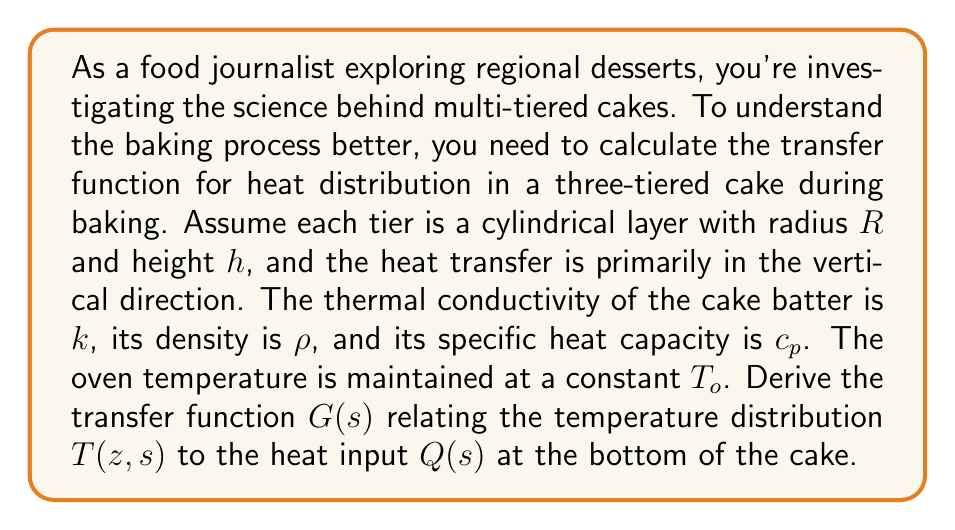Solve this math problem. To solve this problem, we'll follow these steps:

1) First, we need to set up the heat equation for the cake. In one dimension (vertical), it's:

   $$\rho c_p \frac{\partial T}{\partial t} = k \frac{\partial^2 T}{\partial z^2}$$

2) We'll assume the cake is symmetric radially, so we only consider heat transfer in the z-direction.

3) Taking the Laplace transform of both sides with respect to time:

   $$\rho c_p (sT(z,s) - T(z,0)) = k \frac{\partial^2 T(z,s)}{\partial z^2}$$

4) Assuming initial temperature is uniform, $T(z,0) = T_i$, we get:

   $$\rho c_p sT(z,s) - \rho c_p T_i = k \frac{\partial^2 T(z,s)}{\partial z^2}$$

5) Rearranging:

   $$\frac{\partial^2 T(z,s)}{\partial z^2} - \frac{\rho c_p s}{k}T(z,s) = -\frac{\rho c_p T_i}{k}$$

6) This is a second-order ODE. Its general solution is:

   $$T(z,s) = A e^{\sqrt{\frac{\rho c_p s}{k}}z} + B e^{-\sqrt{\frac{\rho c_p s}{k}}z} + \frac{T_i}{s}$$

7) We need boundary conditions. At the bottom (z=0), the heat flux is $Q(s)/A$, where $A = \pi R^2$ is the area of the cake tier. At the top (z=3h), we assume the temperature is the oven temperature $T_o$. These give us:

   $$-k\frac{\partial T}{\partial z}\bigg|_{z=0} = \frac{Q(s)}{\pi R^2}$$
   $$T(3h,s) = \frac{T_o}{s}$$

8) Applying these boundary conditions to solve for A and B, we get:

   $$A = \frac{Q(s)}{k\sqrt{\frac{\rho c_p s}{k}}\pi R^2} \cdot \frac{e^{3h\sqrt{\frac{\rho c_p s}{k}}}}{e^{3h\sqrt{\frac{\rho c_p s}{k}}} + e^{-3h\sqrt{\frac{\rho c_p s}{k}}}}$$

   $$B = \frac{Q(s)}{k\sqrt{\frac{\rho c_p s}{k}}\pi R^2} \cdot \frac{1}{e^{3h\sqrt{\frac{\rho c_p s}{k}}} + e^{-3h\sqrt{\frac{\rho c_p s}{k}}}}$$

9) The transfer function $G(s)$ is defined as $T(z,s)/Q(s)$. Therefore:

   $$G(s) = \frac{1}{k\sqrt{\frac{\rho c_p s}{k}}\pi R^2} \cdot \frac{e^{3h\sqrt{\frac{\rho c_p s}{k}}}e^{-z\sqrt{\frac{\rho c_p s}{k}}} + e^{z\sqrt{\frac{\rho c_p s}{k}}}}{e^{3h\sqrt{\frac{\rho c_p s}{k}}} + e^{-3h\sqrt{\frac{\rho c_p s}{k}}}} + \frac{T_i}{sQ(s)}$$

This is the transfer function relating the temperature distribution to the heat input at any point z in the cake.
Answer: $$G(s) = \frac{1}{k\sqrt{\frac{\rho c_p s}{k}}\pi R^2} \cdot \frac{e^{3h\sqrt{\frac{\rho c_p s}{k}}}e^{-z\sqrt{\frac{\rho c_p s}{k}}} + e^{z\sqrt{\frac{\rho c_p s}{k}}}}{e^{3h\sqrt{\frac{\rho c_p s}{k}}} + e^{-3h\sqrt{\frac{\rho c_p s}{k}}}} + \frac{T_i}{sQ(s)}$$ 